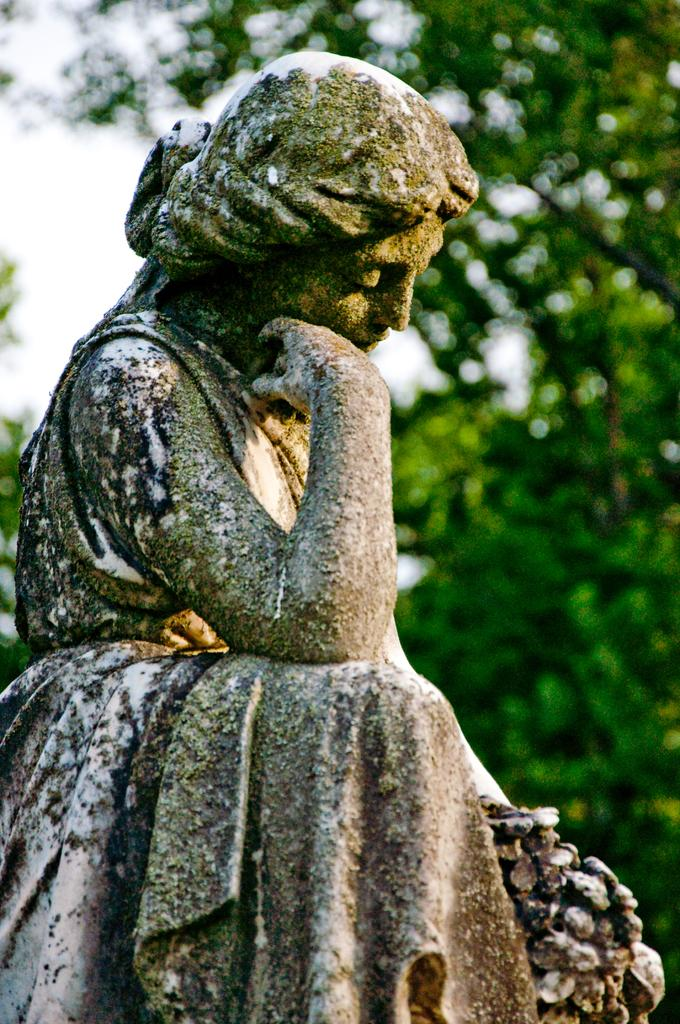What is the main subject in the image? There is a statue in the image. What can be seen in the background of the image? There are trees in the background of the image. How does the statue exchange fuel with the visitors in the image? The statue does not exchange fuel with visitors, as it is a non-living object and cannot engage in such activities. 